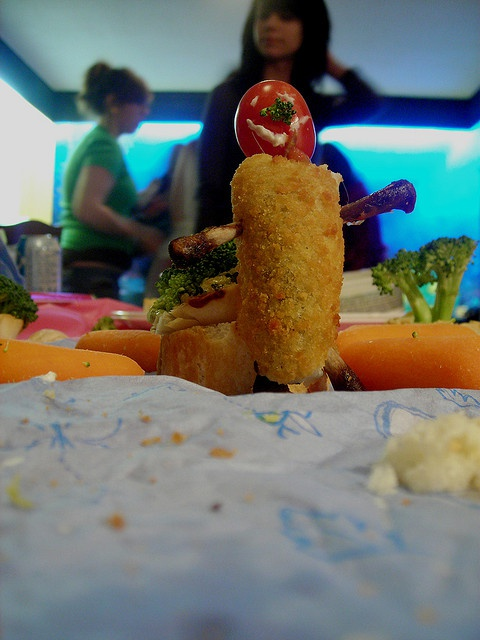Describe the objects in this image and their specific colors. I can see people in teal, black, gray, and darkgreen tones, people in teal, black, maroon, navy, and gray tones, carrot in teal, red, maroon, and orange tones, broccoli in teal, darkgreen, black, and olive tones, and carrot in teal, orange, darkgray, and tan tones in this image. 